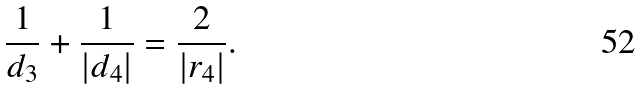Convert formula to latex. <formula><loc_0><loc_0><loc_500><loc_500>\frac { 1 } { d _ { 3 } } + \frac { 1 } { | d _ { 4 } | } = \frac { 2 } { | r _ { 4 } | } .</formula> 